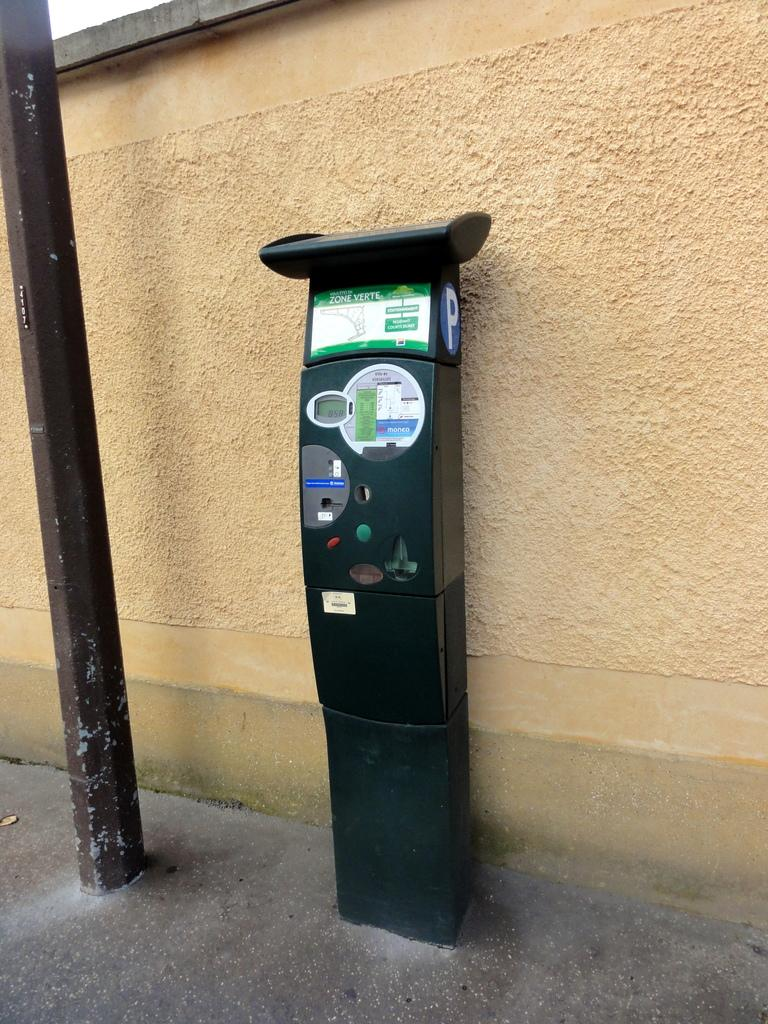What is the main object in the image? There is an ATM machine in the image. Where is the ATM machine located? The ATM machine is in front of a wall. Is there any other object near the ATM machine? Yes, there is a pole beside the ATM machine. What color are the tomatoes on the ATM machine? There are no tomatoes present on the ATM machine in the image. 